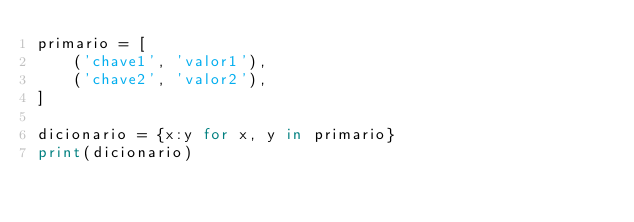<code> <loc_0><loc_0><loc_500><loc_500><_Python_>primario = [
    ('chave1', 'valor1'),
    ('chave2', 'valor2'),
]

dicionario = {x:y for x, y in primario}
print(dicionario)</code> 